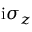Convert formula to latex. <formula><loc_0><loc_0><loc_500><loc_500>i \sigma _ { z }</formula> 